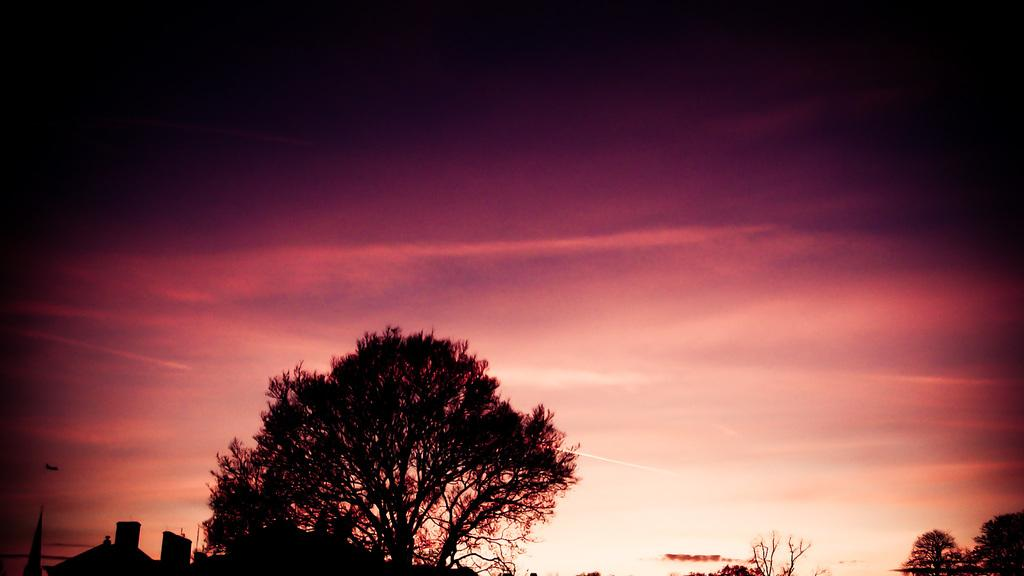What time of day is depicted in the image? The image is taken in the evening light. What type of natural elements can be seen in the image? There are trees visible in the image. What type of man-made structures are visible in the image? The top portions of buildings are visible in the image. What is visible at the top of the image? The sky is visible at the top of the image. What type of line is being drawn by the doctor in the middle of the image? There is no doctor or line present in the image. 